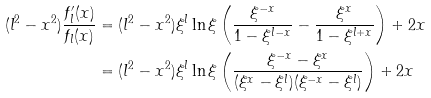<formula> <loc_0><loc_0><loc_500><loc_500>( l ^ { 2 } - x ^ { 2 } ) \frac { f ^ { \prime } _ { l } ( x ) } { f _ { l } ( x ) } & = ( l ^ { 2 } - x ^ { 2 } ) \xi ^ { l } \ln \xi \left ( \frac { \xi ^ { - x } } { 1 - \xi ^ { l - x } } - \frac { \xi ^ { x } } { 1 - \xi ^ { l + x } } \right ) + 2 x \\ & = ( l ^ { 2 } - x ^ { 2 } ) \xi ^ { l } \ln \xi \left ( \frac { \xi ^ { - x } - \xi ^ { x } } { ( \xi ^ { x } - \xi ^ { l } ) ( \xi ^ { - x } - \xi ^ { l } ) } \right ) + 2 x</formula> 